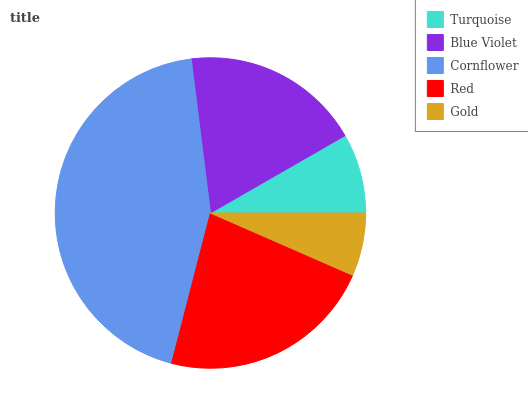Is Gold the minimum?
Answer yes or no. Yes. Is Cornflower the maximum?
Answer yes or no. Yes. Is Blue Violet the minimum?
Answer yes or no. No. Is Blue Violet the maximum?
Answer yes or no. No. Is Blue Violet greater than Turquoise?
Answer yes or no. Yes. Is Turquoise less than Blue Violet?
Answer yes or no. Yes. Is Turquoise greater than Blue Violet?
Answer yes or no. No. Is Blue Violet less than Turquoise?
Answer yes or no. No. Is Blue Violet the high median?
Answer yes or no. Yes. Is Blue Violet the low median?
Answer yes or no. Yes. Is Gold the high median?
Answer yes or no. No. Is Cornflower the low median?
Answer yes or no. No. 